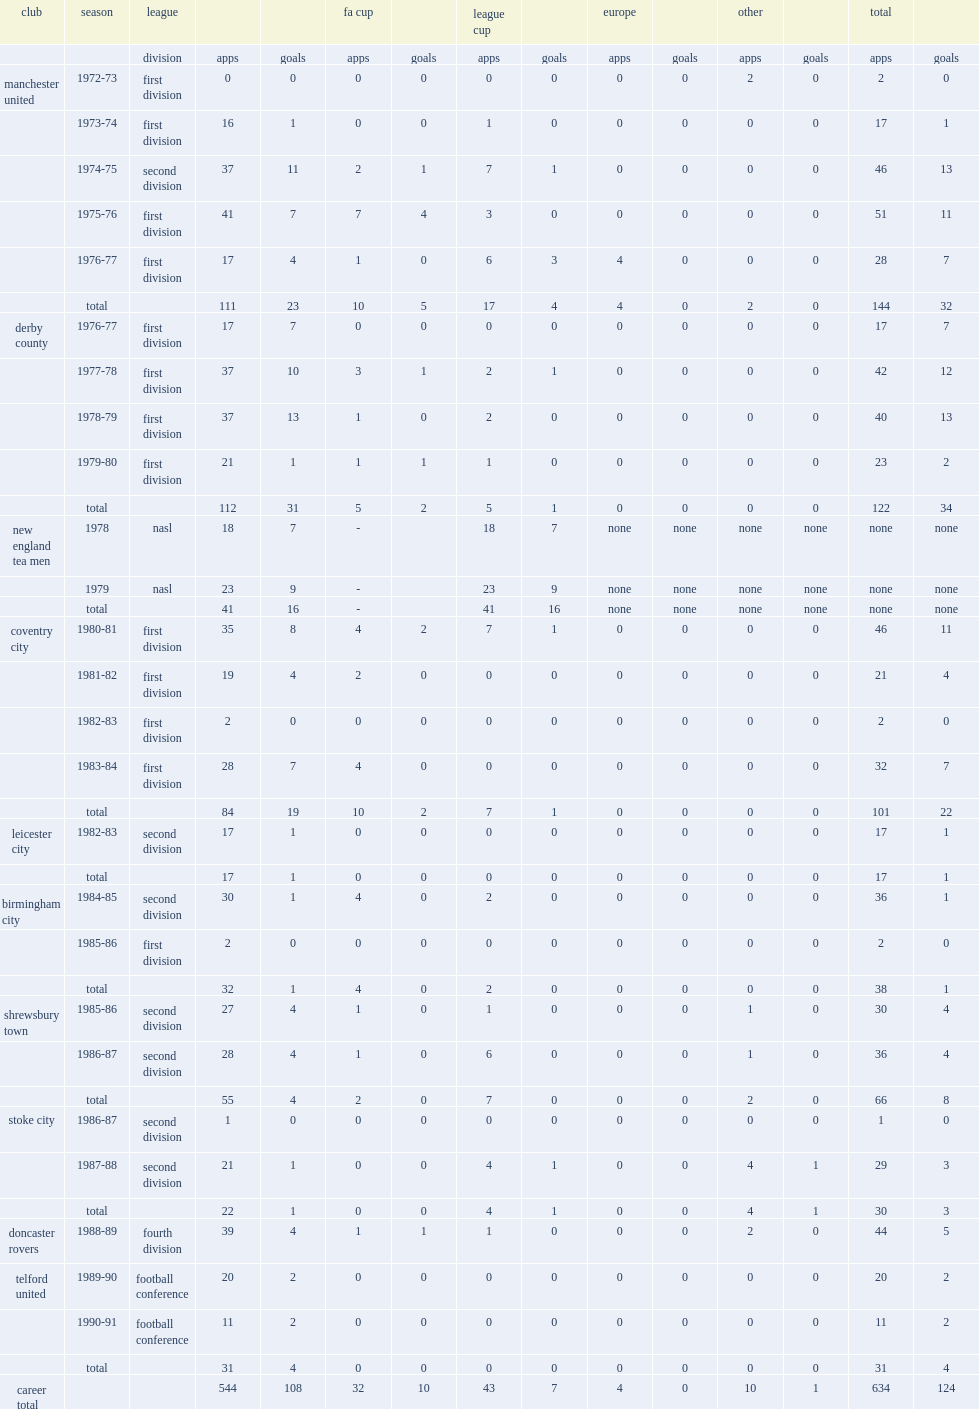How many matches did gerry daly play for doncaster rovers totally in 1988-89? 44.0. 